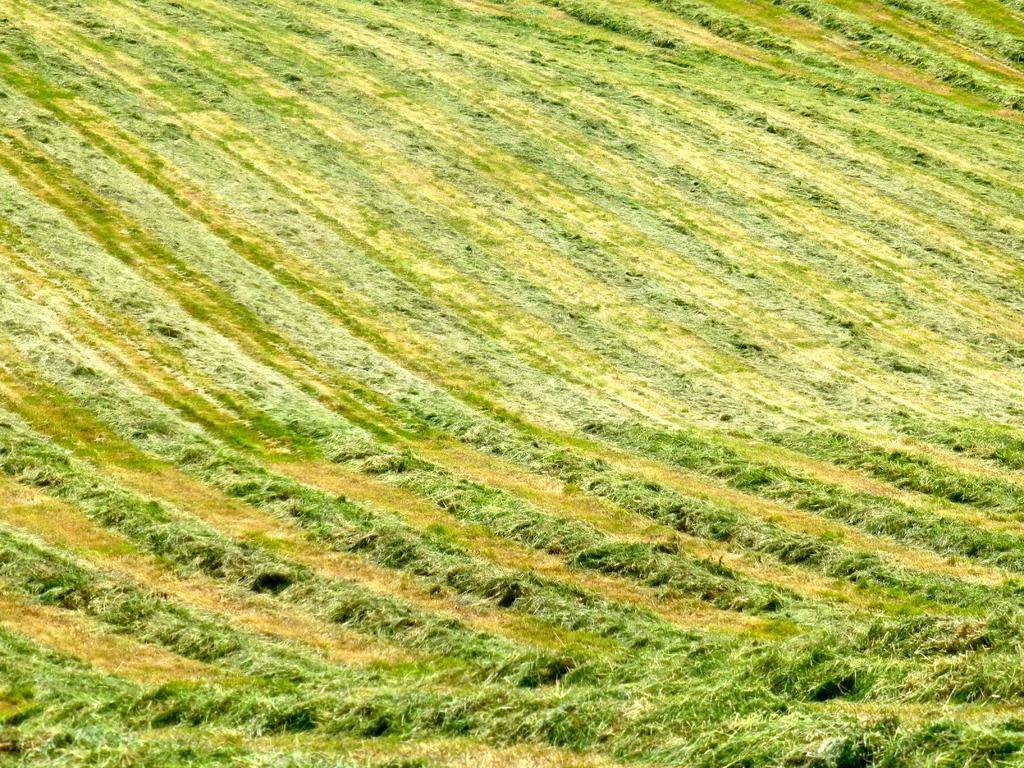Please provide a concise description of this image. Here we can see grass in green color. 